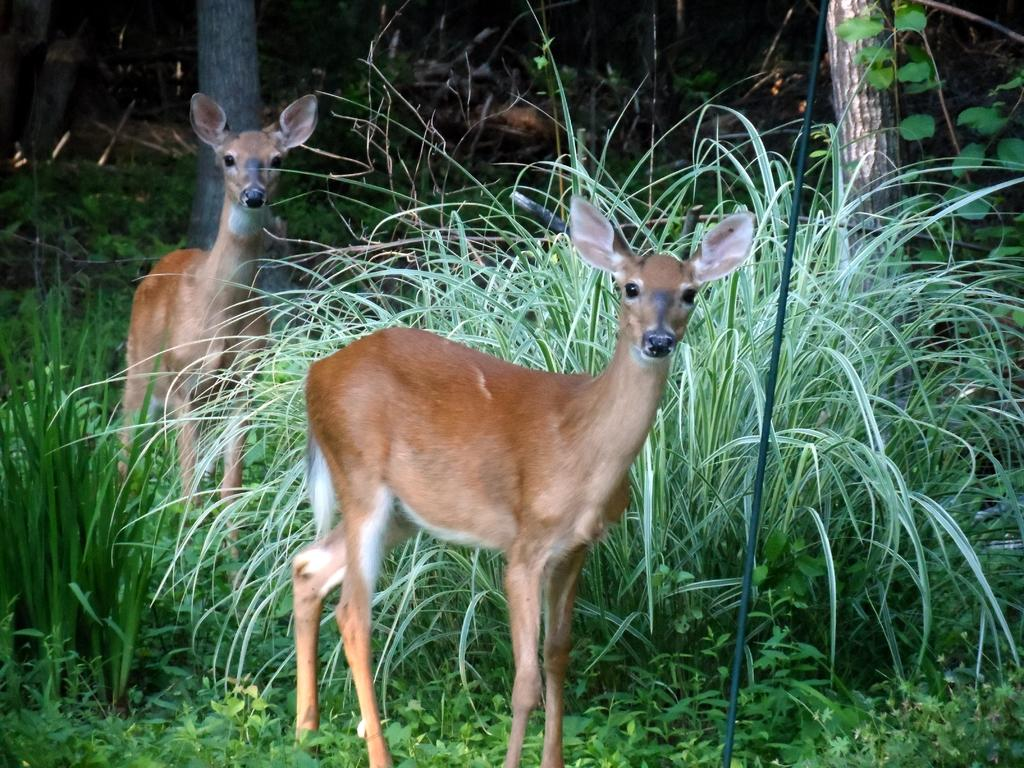What animals can be seen on the ground in the image? There are two deer on the ground in the image. What type of vegetation is present in the image? There are plants, trees, and grass in the image. What type of plane can be seen flying over the deer in the image? There is no plane visible in the image; it only features two deer on the ground, plants, trees, and grass. 